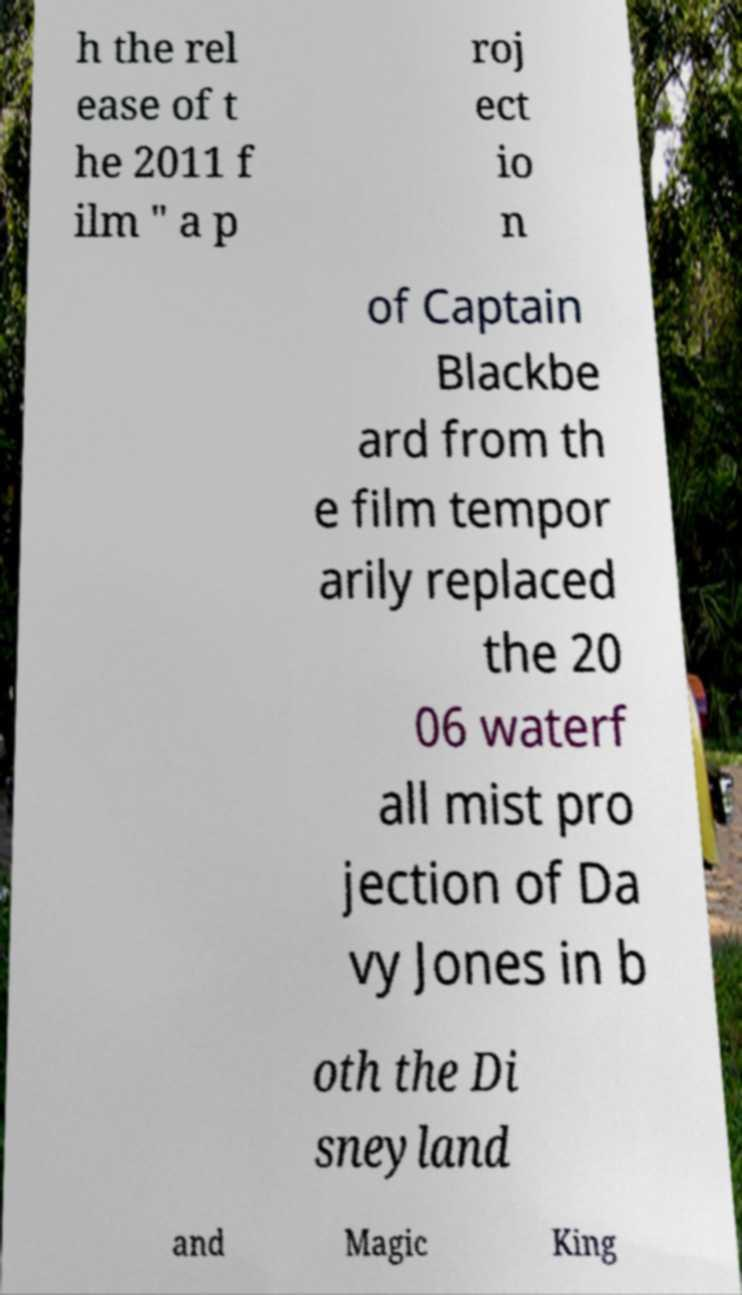For documentation purposes, I need the text within this image transcribed. Could you provide that? h the rel ease of t he 2011 f ilm " a p roj ect io n of Captain Blackbe ard from th e film tempor arily replaced the 20 06 waterf all mist pro jection of Da vy Jones in b oth the Di sneyland and Magic King 